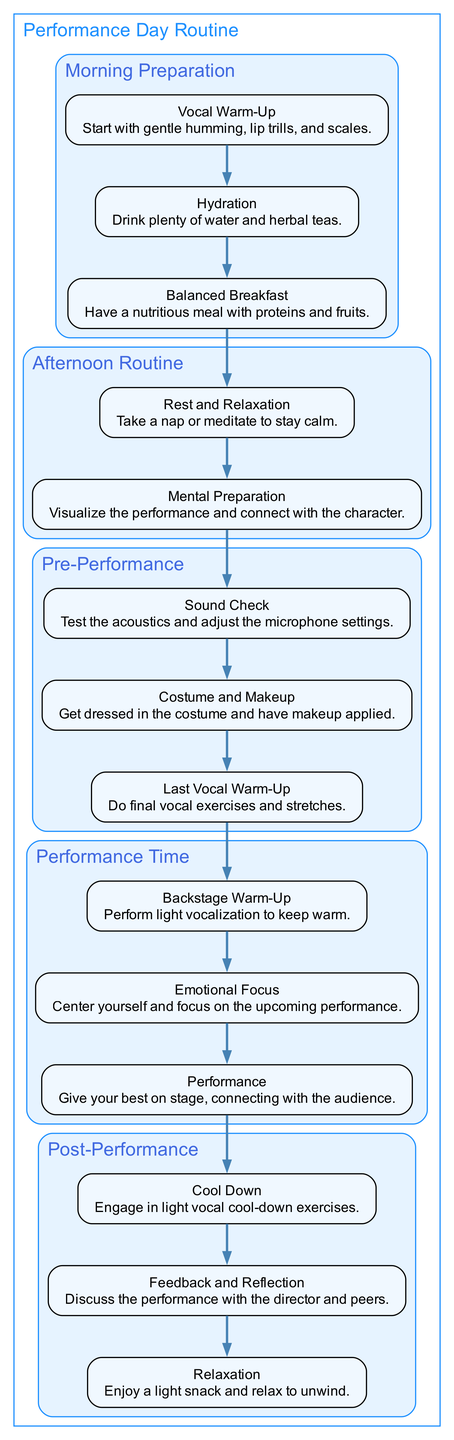What is the first step of the Morning Preparation segment? The first step in the "Morning Preparation" segment is "Vocal Warm-Up," which entails starting with gentle humming, lip trills, and scales.
Answer: Vocal Warm-Up How many steps are in the Pre-Performance segment? In the "Pre-Performance" segment, there are three steps: "Sound Check," "Costume and Makeup," and "Last Vocal Warm-Up." Counting these steps gives a total of three.
Answer: 3 What is the last activity in the Performance Time segment? The last activity in the "Performance Time" segment is "Performance," where the person gives their best on stage, connecting with the audience.
Answer: Performance What segment follows the Afternoon Routine? The segment that follows the "Afternoon Routine" is the "Pre-Performance" segment. This relationship can be determined by examining the sequential order of segments in the diagram.
Answer: Pre-Performance Which step is directly before Feedback and Reflection? The step directly before "Feedback and Reflection" is "Cool Down." This can be identified by the adjacent placement of these steps in the "Post-Performance" segment within the diagram.
Answer: Cool Down How many segments are there in total? There are five segments in total: "Morning Preparation," "Afternoon Routine," "Pre-Performance," "Performance Time," and "Post-Performance." By counting each of the listed segments, we arrive at the total.
Answer: 5 What is the focus during the Emotional Focus step? The focus during the "Emotional Focus" step is to center oneself and concentrate on the upcoming performance. This can be understood from the description provided for that step.
Answer: Center yourself What activity is emphasized in the Rest and Relaxation step? The activity emphasized in the "Rest and Relaxation" step is to take a nap or meditate in order to stay calm. This is specified in the description of that step.
Answer: Take a nap or meditate Which step in the Afternoon Routine is related to visualization? The step in the "Afternoon Routine" related to visualization is "Mental Preparation," where one visualizes the performance and connects with the character. This connection is drawn from the description provided.
Answer: Mental Preparation 